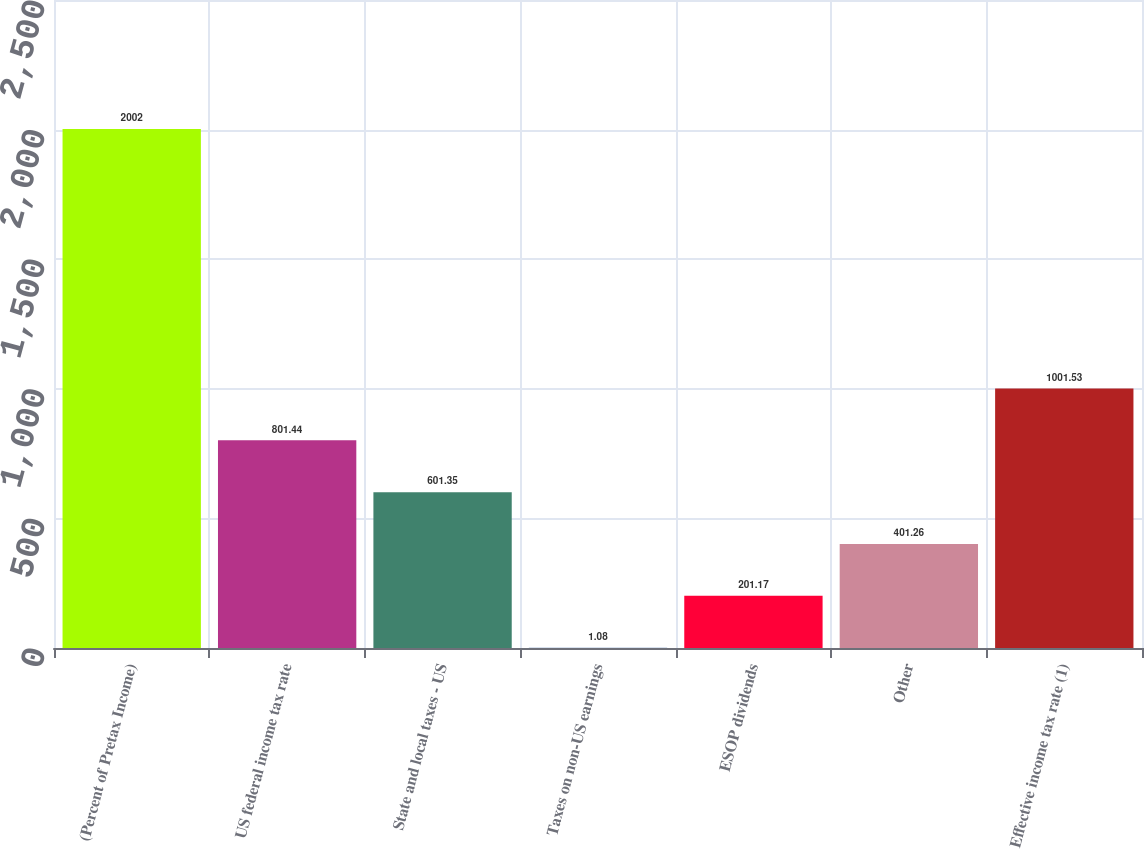<chart> <loc_0><loc_0><loc_500><loc_500><bar_chart><fcel>(Percent of Pretax Income)<fcel>US federal income tax rate<fcel>State and local taxes - US<fcel>Taxes on non-US earnings<fcel>ESOP dividends<fcel>Other<fcel>Effective income tax rate (1)<nl><fcel>2002<fcel>801.44<fcel>601.35<fcel>1.08<fcel>201.17<fcel>401.26<fcel>1001.53<nl></chart> 